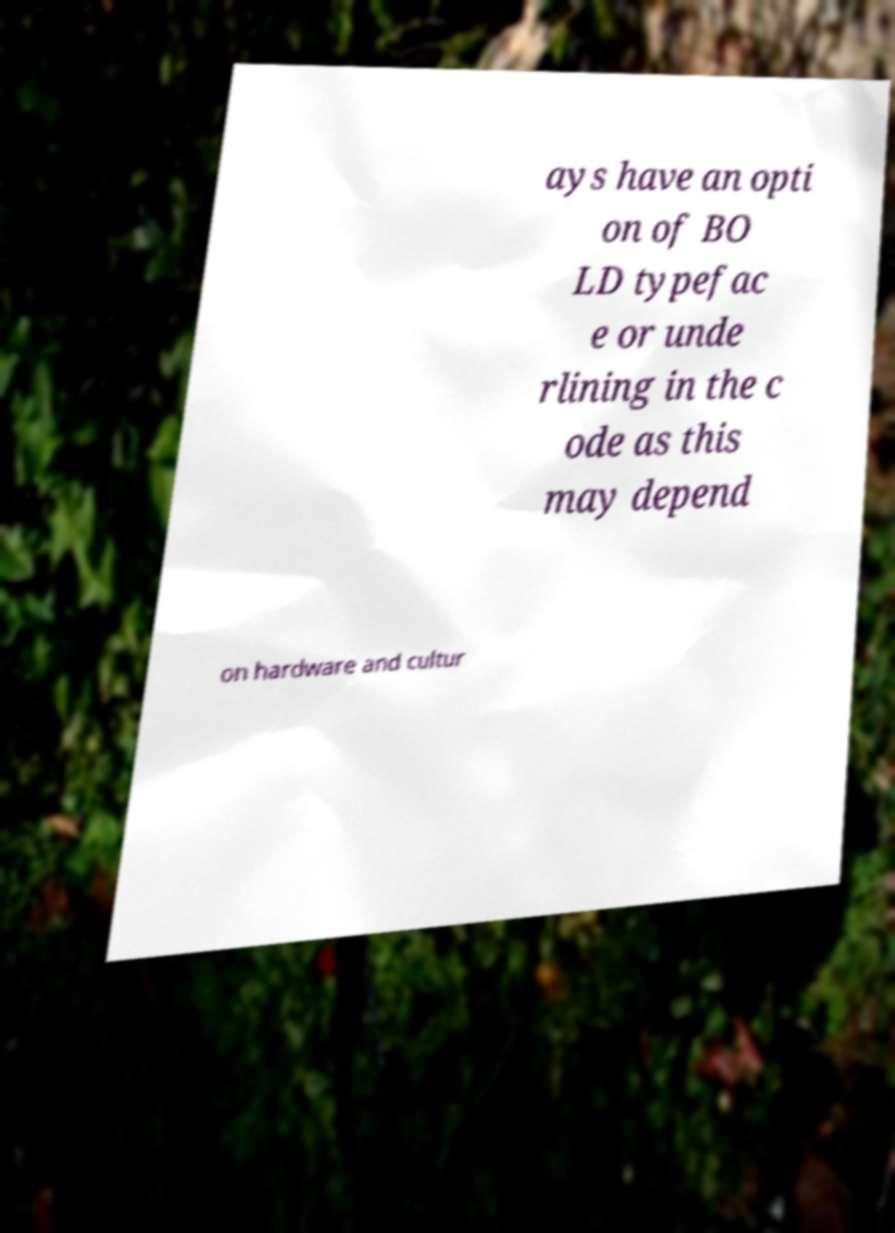For documentation purposes, I need the text within this image transcribed. Could you provide that? ays have an opti on of BO LD typefac e or unde rlining in the c ode as this may depend on hardware and cultur 